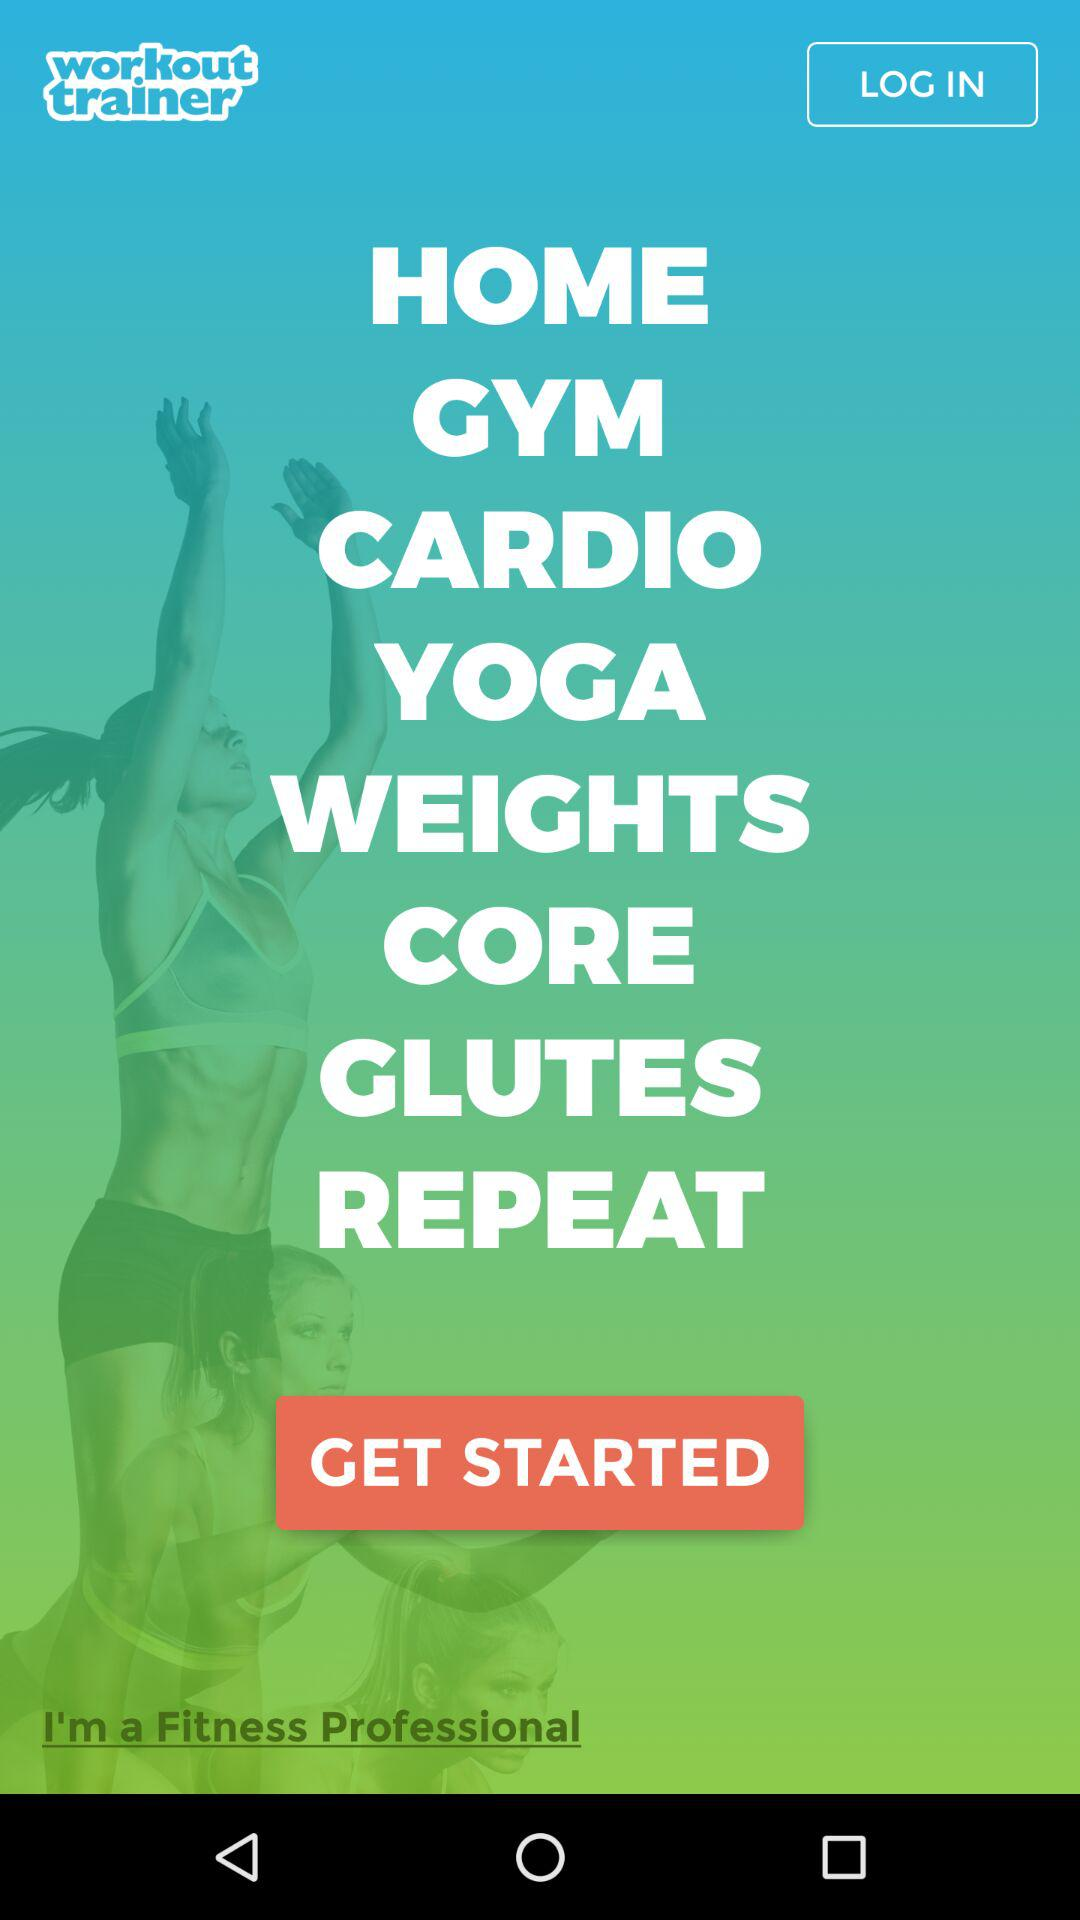What is the name of the application? The application name is "workout trainer". 